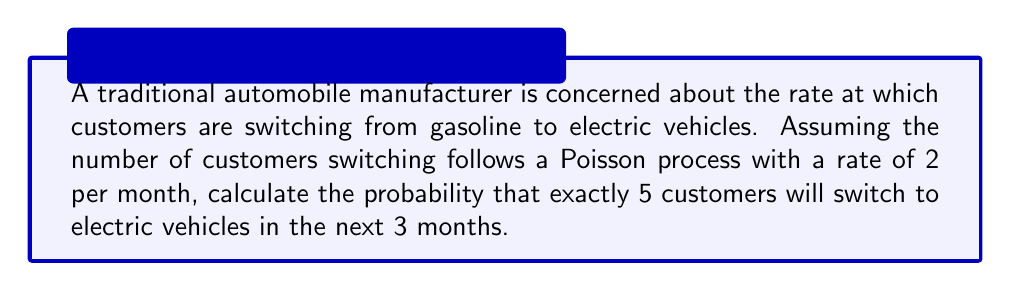Could you help me with this problem? To solve this problem, we'll use the Poisson distribution formula:

$$P(X = k) = \frac{e^{-\lambda} \lambda^k}{k!}$$

Where:
$\lambda$ = rate * time
$k$ = number of events
$e$ = Euler's number (approximately 2.71828)

Step 1: Calculate $\lambda$
$\lambda = 2 \text{ customers/month} * 3 \text{ months} = 6$

Step 2: Plug values into the Poisson distribution formula
$$P(X = 5) = \frac{e^{-6} 6^5}{5!}$$

Step 3: Calculate the numerator
$e^{-6} \approx 0.00248$
$6^5 = 7776$
$e^{-6} * 6^5 \approx 19.2845$

Step 4: Calculate the denominator
$5! = 5 * 4 * 3 * 2 * 1 = 120$

Step 5: Divide the numerator by the denominator
$$\frac{19.2845}{120} \approx 0.1607$$

Therefore, the probability of exactly 5 customers switching to electric vehicles in the next 3 months is approximately 0.1607 or 16.07%.
Answer: $0.1607$ or $16.07\%$ 